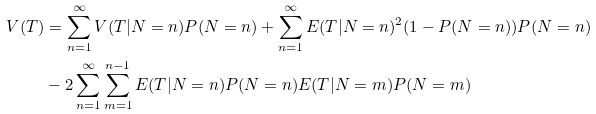Convert formula to latex. <formula><loc_0><loc_0><loc_500><loc_500>V ( T ) & = \sum _ { n = 1 } ^ { \infty } V ( T | N = n ) P ( N = n ) + \sum _ { n = 1 } ^ { \infty } E ( T | N = n ) ^ { 2 } ( 1 - P ( N = n ) ) P ( N = n ) \\ & - 2 \sum _ { n = 1 } ^ { \infty } \sum _ { m = 1 } ^ { n - 1 } E ( T | N = n ) P ( N = n ) E ( T | N = m ) P ( N = m )</formula> 